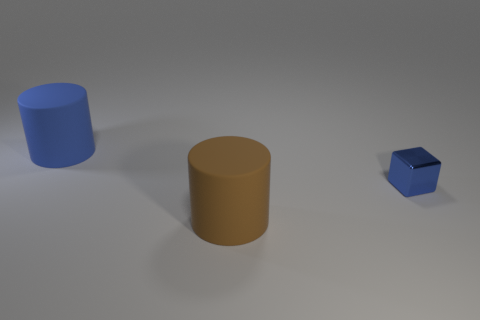How many objects are either brown metal cubes or big blue cylinders behind the shiny object?
Provide a short and direct response. 1. There is a matte thing behind the tiny metal block; does it have the same size as the blue metal object on the right side of the blue rubber thing?
Make the answer very short. No. Is there a big thing that has the same material as the large brown cylinder?
Provide a succinct answer. Yes. What shape is the large blue matte object?
Provide a succinct answer. Cylinder. There is a brown thing that is right of the matte cylinder that is to the left of the big brown matte object; what is its shape?
Your response must be concise. Cylinder. How many other things are there of the same shape as the tiny thing?
Make the answer very short. 0. There is a thing that is on the right side of the matte object right of the blue cylinder; what is its size?
Provide a succinct answer. Small. Are any blue cubes visible?
Provide a succinct answer. Yes. There is a big matte thing that is in front of the small blue object; how many large cylinders are behind it?
Ensure brevity in your answer.  1. The blue thing that is behind the small shiny cube has what shape?
Offer a terse response. Cylinder. 